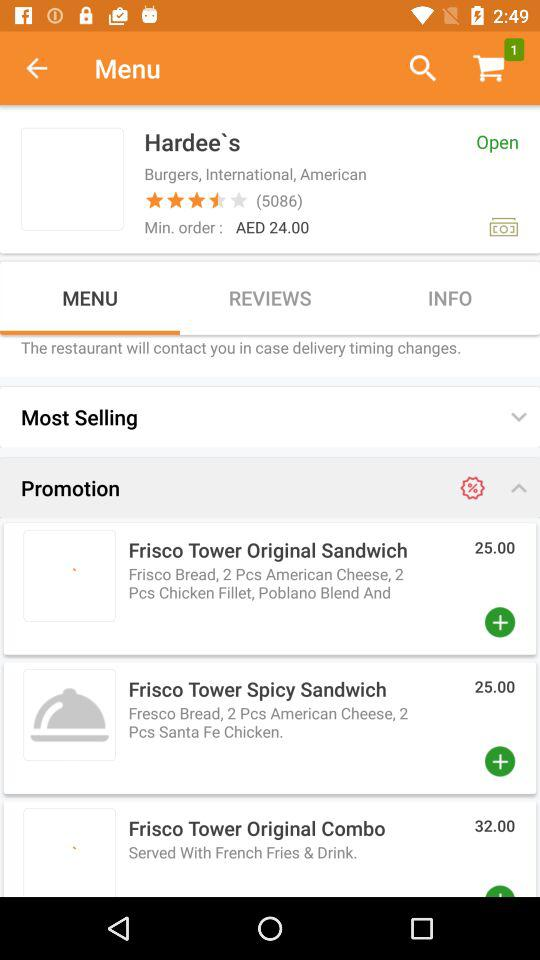What is the price of the "Frisco Tower Original Sandwich"? The price is 25. 